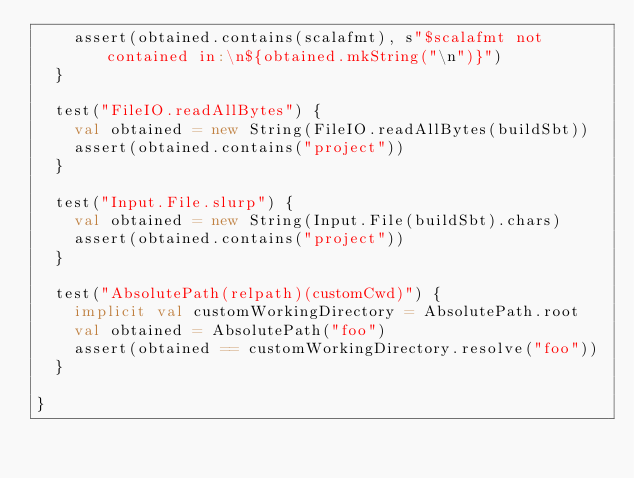<code> <loc_0><loc_0><loc_500><loc_500><_Scala_>    assert(obtained.contains(scalafmt), s"$scalafmt not contained in:\n${obtained.mkString("\n")}")
  }

  test("FileIO.readAllBytes") {
    val obtained = new String(FileIO.readAllBytes(buildSbt))
    assert(obtained.contains("project"))
  }

  test("Input.File.slurp") {
    val obtained = new String(Input.File(buildSbt).chars)
    assert(obtained.contains("project"))
  }

  test("AbsolutePath(relpath)(customCwd)") {
    implicit val customWorkingDirectory = AbsolutePath.root
    val obtained = AbsolutePath("foo")
    assert(obtained == customWorkingDirectory.resolve("foo"))
  }

}
</code> 